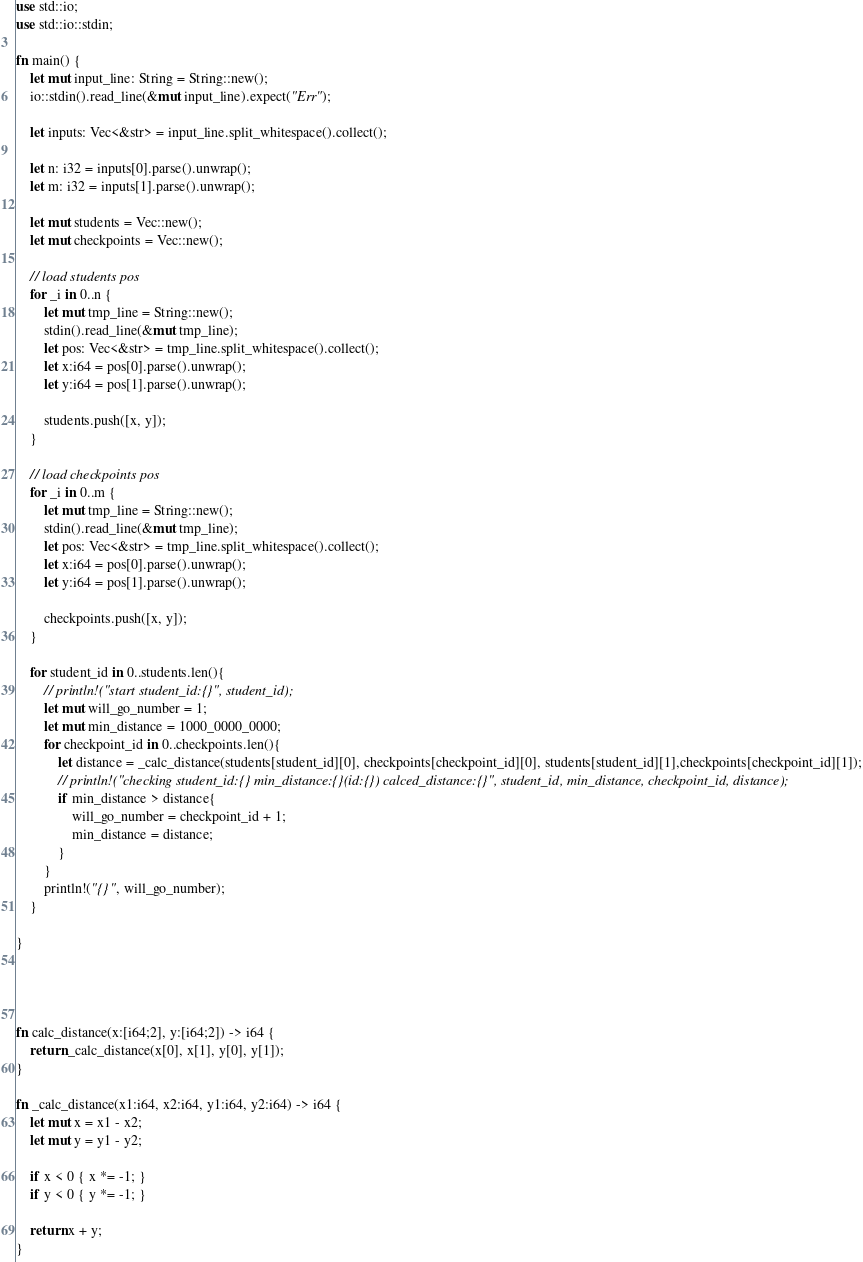Convert code to text. <code><loc_0><loc_0><loc_500><loc_500><_Rust_>use std::io;
use std::io::stdin;

fn main() {
    let mut input_line: String = String::new();
    io::stdin().read_line(&mut input_line).expect("Err");

    let inputs: Vec<&str> = input_line.split_whitespace().collect();

    let n: i32 = inputs[0].parse().unwrap();
    let m: i32 = inputs[1].parse().unwrap();

    let mut students = Vec::new();
    let mut checkpoints = Vec::new();

    // load students pos
    for _i in 0..n {
        let mut tmp_line = String::new();
        stdin().read_line(&mut tmp_line);
        let pos: Vec<&str> = tmp_line.split_whitespace().collect();
        let x:i64 = pos[0].parse().unwrap();
        let y:i64 = pos[1].parse().unwrap();

        students.push([x, y]);
    }

    // load checkpoints pos
    for _i in 0..m {
        let mut tmp_line = String::new();
        stdin().read_line(&mut tmp_line);
        let pos: Vec<&str> = tmp_line.split_whitespace().collect();
        let x:i64 = pos[0].parse().unwrap();
        let y:i64 = pos[1].parse().unwrap();

        checkpoints.push([x, y]);
    }

    for student_id in 0..students.len(){
        // println!("start student_id:{}", student_id);
        let mut will_go_number = 1;
        let mut min_distance = 1000_0000_0000;
        for checkpoint_id in 0..checkpoints.len(){
            let distance = _calc_distance(students[student_id][0], checkpoints[checkpoint_id][0], students[student_id][1],checkpoints[checkpoint_id][1]);
            // println!("checking student_id:{} min_distance:{}(id:{}) calced_distance:{}", student_id, min_distance, checkpoint_id, distance);
            if min_distance > distance{
                will_go_number = checkpoint_id + 1;
                min_distance = distance;
            }
        }
        println!("{}", will_go_number);
    }

}




fn calc_distance(x:[i64;2], y:[i64;2]) -> i64 {
    return _calc_distance(x[0], x[1], y[0], y[1]);
}

fn _calc_distance(x1:i64, x2:i64, y1:i64, y2:i64) -> i64 {
    let mut x = x1 - x2;
    let mut y = y1 - y2;

    if x < 0 { x *= -1; }
    if y < 0 { y *= -1; }

    return x + y;
}</code> 